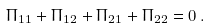<formula> <loc_0><loc_0><loc_500><loc_500>\Pi _ { 1 1 } + \Pi _ { 1 2 } + \Pi _ { 2 1 } + \Pi _ { 2 2 } = 0 \, .</formula> 